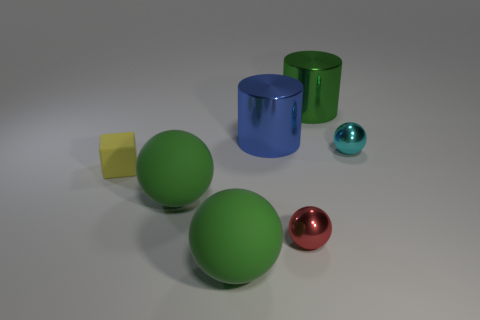The big sphere that is in front of the metal ball that is in front of the tiny object that is right of the big green shiny thing is made of what material?
Keep it short and to the point. Rubber. How many objects are either small things or tiny shiny balls in front of the yellow thing?
Your answer should be compact. 3. There is a metallic sphere in front of the cyan thing; is its color the same as the tiny rubber object?
Your response must be concise. No. Are there more tiny metal spheres to the left of the red shiny object than yellow matte things on the left side of the small yellow matte block?
Offer a very short reply. No. Is there anything else that is the same color as the matte block?
Your answer should be very brief. No. What number of things are either big purple rubber objects or big metallic things?
Your response must be concise. 2. There is a green thing that is to the right of the blue shiny thing; is its size the same as the cyan metal object?
Offer a terse response. No. How many other objects are there of the same size as the blue metallic cylinder?
Ensure brevity in your answer.  3. Are there any green objects?
Give a very brief answer. Yes. There is a green sphere behind the tiny ball that is in front of the yellow cube; what is its size?
Your response must be concise. Large. 